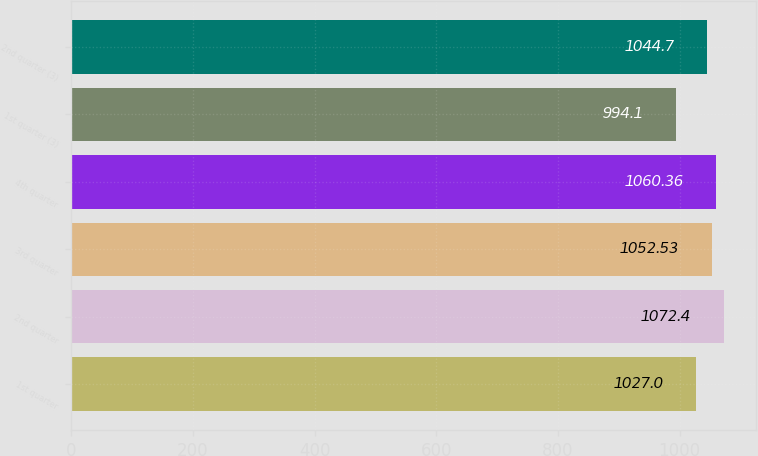Convert chart to OTSL. <chart><loc_0><loc_0><loc_500><loc_500><bar_chart><fcel>1st quarter<fcel>2nd quarter<fcel>3rd quarter<fcel>4th quarter<fcel>1st quarter (3)<fcel>2nd quarter (3)<nl><fcel>1027<fcel>1072.4<fcel>1052.53<fcel>1060.36<fcel>994.1<fcel>1044.7<nl></chart> 